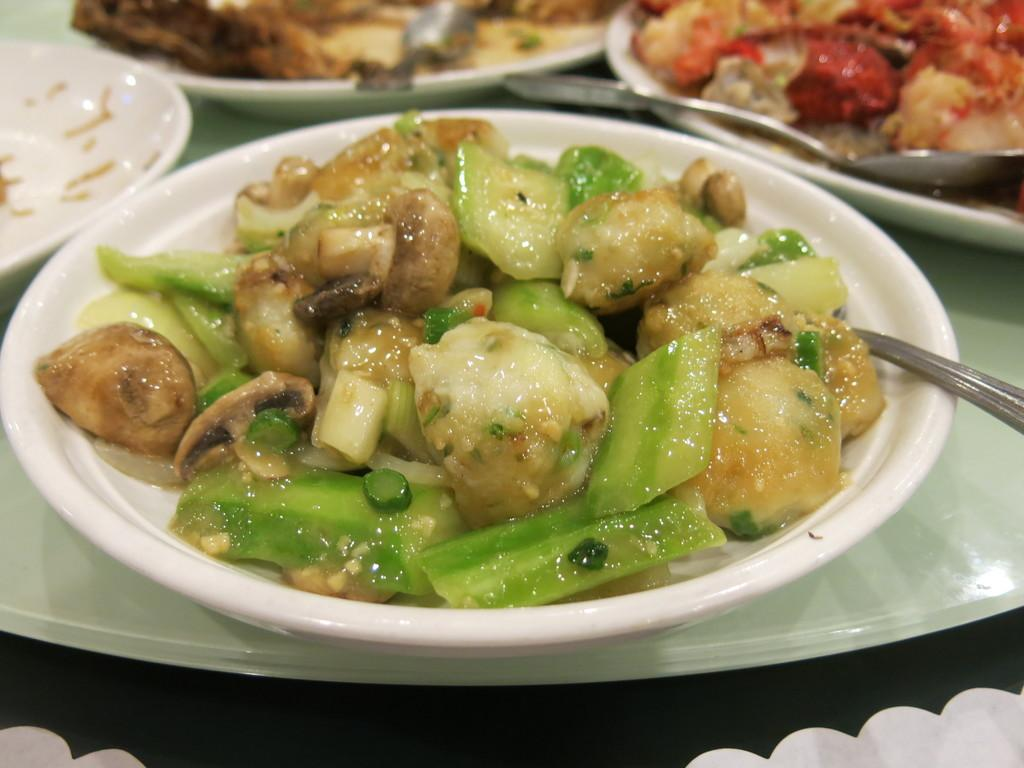What can be seen on the plates in the image? There are plates of food items in the image. What utensils are present in the image? There are spoons in the image. Where are the plates and spoons located? The plates and spoons are placed on a table. What type of thread is being used to hold the popcorn in the image? There is no popcorn present in the image, and therefore no thread is being used to hold it. 